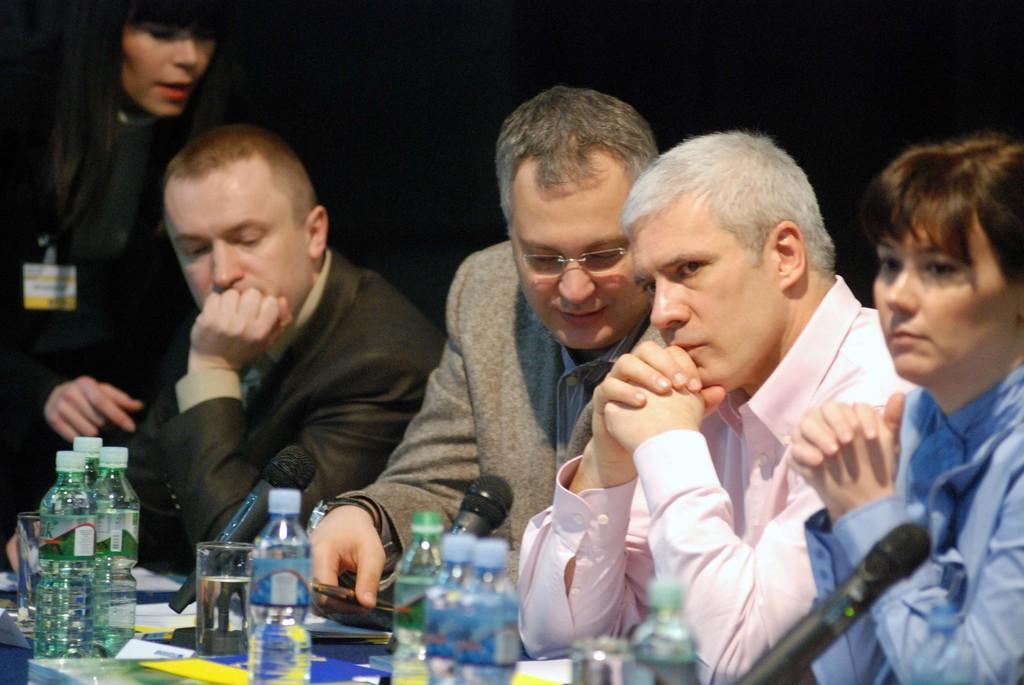Who or what is present in the image? There are people in the image. Where are the people located in relation to other objects? The people are beside a table. What items can be seen on the table? There are water bottles and a glass on the table. What type of seed is being planted in the cave in the image? There is no cave or seed present in the image. 